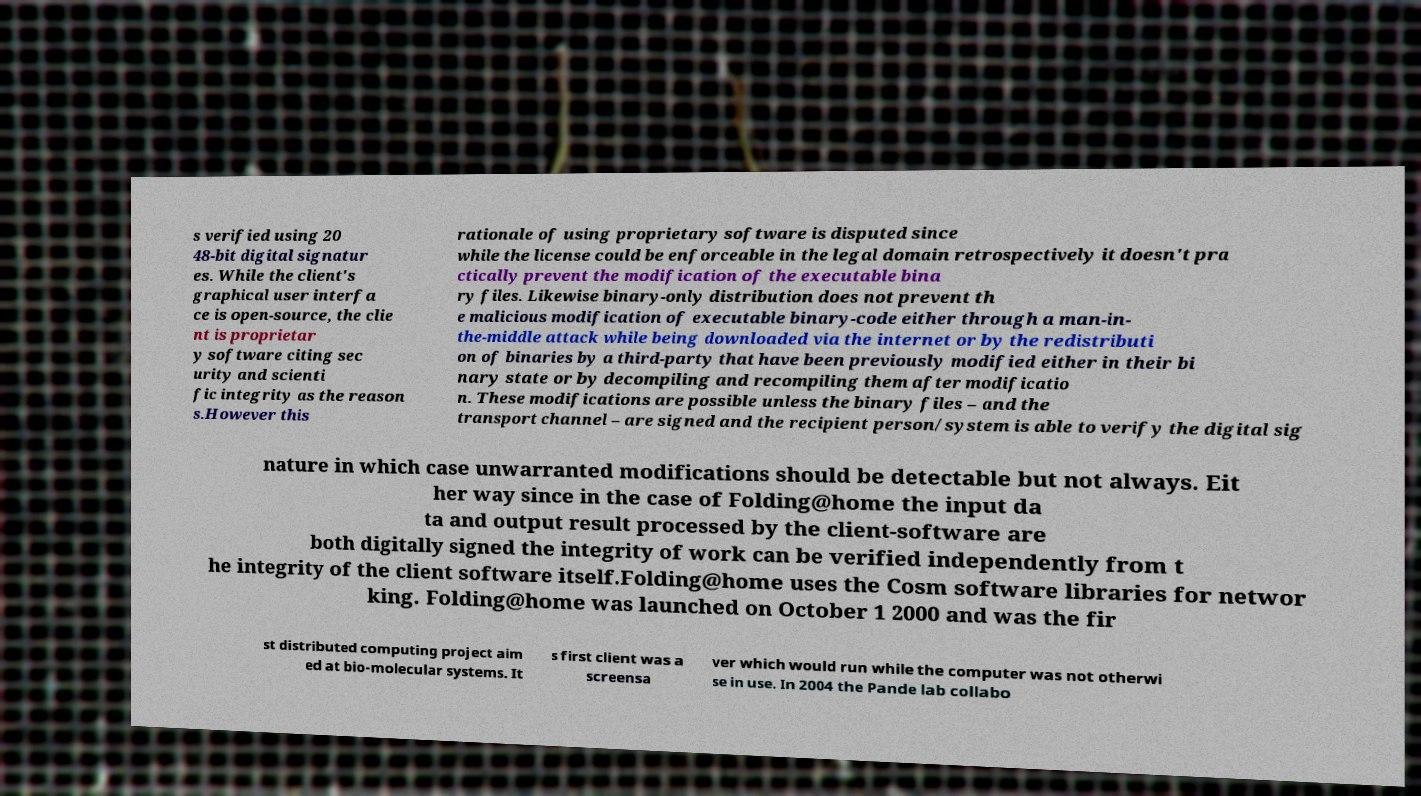Please read and relay the text visible in this image. What does it say? s verified using 20 48-bit digital signatur es. While the client's graphical user interfa ce is open-source, the clie nt is proprietar y software citing sec urity and scienti fic integrity as the reason s.However this rationale of using proprietary software is disputed since while the license could be enforceable in the legal domain retrospectively it doesn't pra ctically prevent the modification of the executable bina ry files. Likewise binary-only distribution does not prevent th e malicious modification of executable binary-code either through a man-in- the-middle attack while being downloaded via the internet or by the redistributi on of binaries by a third-party that have been previously modified either in their bi nary state or by decompiling and recompiling them after modificatio n. These modifications are possible unless the binary files – and the transport channel – are signed and the recipient person/system is able to verify the digital sig nature in which case unwarranted modifications should be detectable but not always. Eit her way since in the case of Folding@home the input da ta and output result processed by the client-software are both digitally signed the integrity of work can be verified independently from t he integrity of the client software itself.Folding@home uses the Cosm software libraries for networ king. Folding@home was launched on October 1 2000 and was the fir st distributed computing project aim ed at bio-molecular systems. It s first client was a screensa ver which would run while the computer was not otherwi se in use. In 2004 the Pande lab collabo 